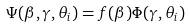<formula> <loc_0><loc_0><loc_500><loc_500>\Psi ( \beta , \gamma , \theta _ { i } ) = f ( \beta ) \Phi ( \gamma , \theta _ { i } )</formula> 